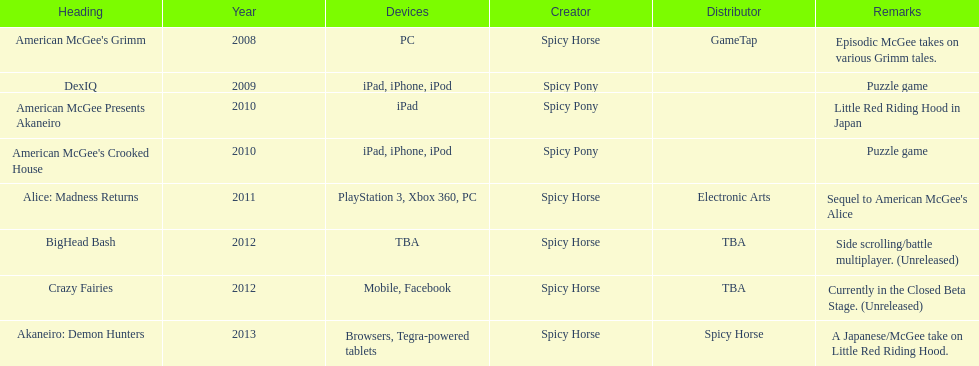What are the number of times an ipad was used as a platform? 3. 